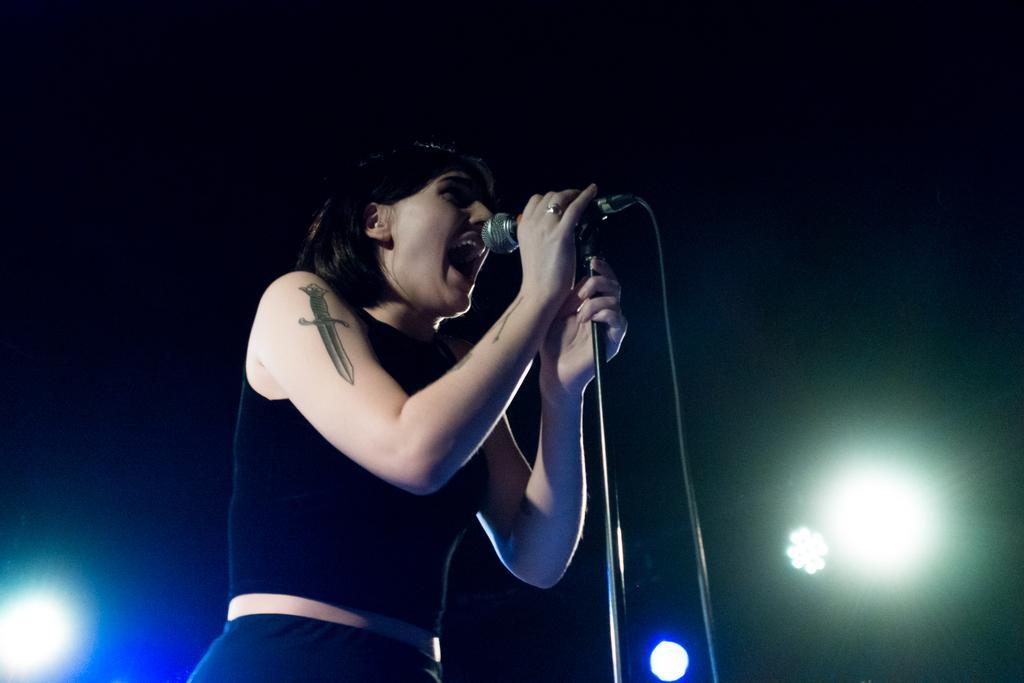How would you summarize this image in a sentence or two? A woman is standing and singing on the microphone behind her there are lights. 